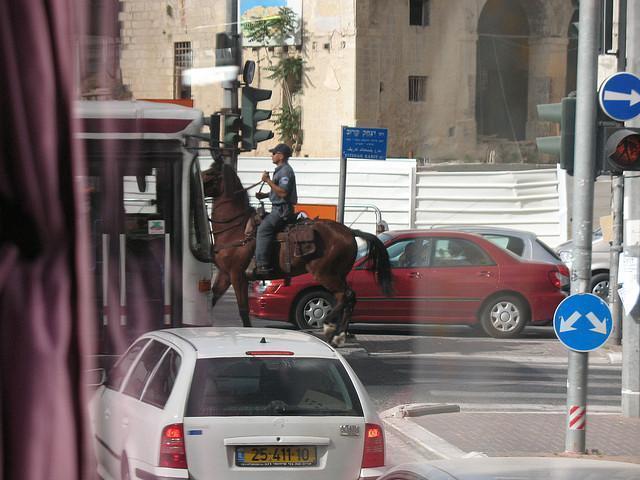Is the statement "The horse is behind the bus." accurate regarding the image?
Answer yes or no. Yes. 